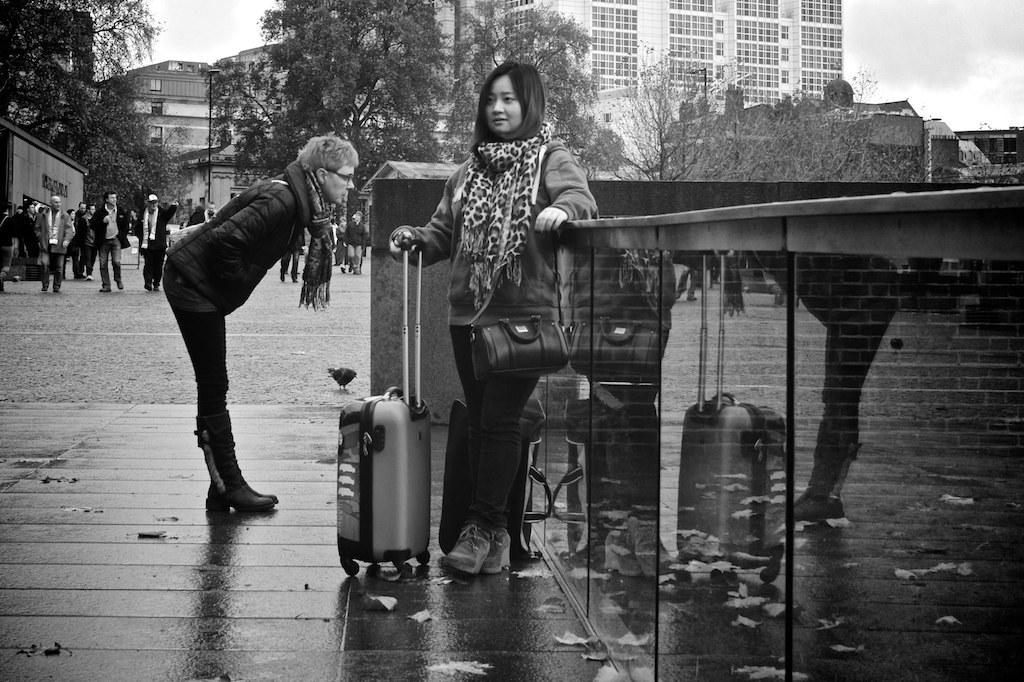What are the people in the image doing? There are people standing in the image. Can you describe what the woman is holding? The woman is holding a trolley bag. What is happening in the background of the image? There are people walking in the background. What type of vegetation can be seen in the image? Trees are visible in the image. What type of structures are present in the image? Buildings are present in the image. How would you describe the weather based on the image? The sky is cloudy in the image. How many clams can be seen on the bridge in the image? There is no bridge or clams present in the image. 